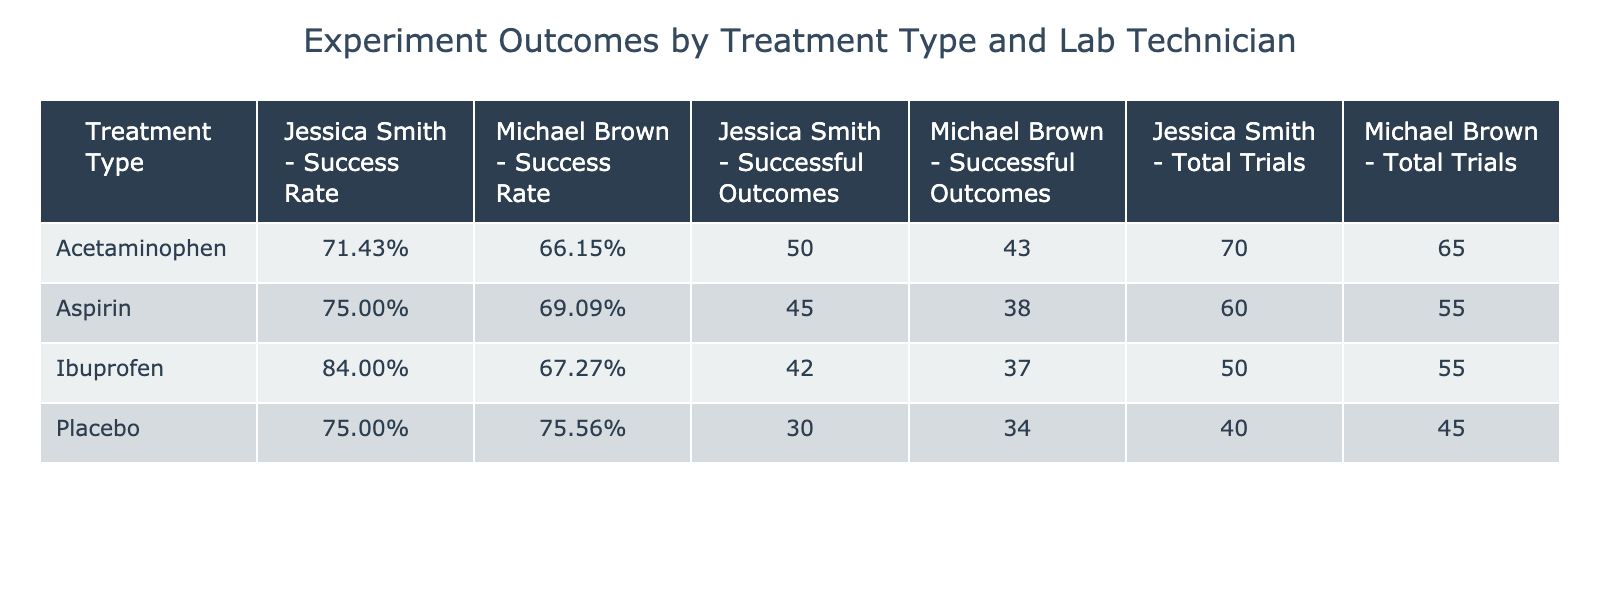What is the success rate for Aspirin when administered by Jessica Smith? To find this, locate the row corresponding to Aspirin and Jessica Smith in the table. The success rate is given as 45 successful outcomes out of 60 trials. Calculating this gives 45/60 = 0.75 or 75%.
Answer: 75% Which lab technician had the highest success rate for Acetaminophen? The success rates for Acetaminophen are: Jessica Smith with 50/70 = 0.714 (71.4%) and Michael Brown with 43/65 = 0.662 (66.2%). Jessica Smith has the higher success rate.
Answer: Jessica Smith What is the average success rate for Ibuprofen across both technicians? The success rates for Ibuprofen are: Jessica Smith with 42/50 = 0.84 (84%) and Michael Brown with 37/55 = 0.673 (67.3%). Adding these gives 0.84 + 0.673 = 1.513. Dividing by 2 to find the average gives 1.513/2 = 0.7565, or 75.65%.
Answer: 75.65% Is the success rate for the placebo treatment higher with Michael Brown than with Jessica Smith? The success rates for placebo are: Michael Brown with 34/45 = 0.756 (75.6%) and Jessica Smith with 30/40 = 0.75 (75%). Therefore, 75.6% is higher than 75%.
Answer: Yes What is the total number of successful outcomes across all treatments for Michael Brown? To find this, sum the successful outcomes for Michael Brown across all treatments: Aspirin (38) + Ibuprofen (37) + Acetaminophen (43) + Placebo (34). This equals 38 + 37 + 43 + 34 = 152 successful outcomes.
Answer: 152 If both technicians used the same treatment type, how many more successful outcomes did Jessica Smith achieve for Aspirin than Michael Brown? For Aspirin, Jessica Smith had 45 successful outcomes and Michael Brown had 38 successful outcomes. The difference is 45 - 38 = 7 successful outcomes more for Jessica Smith.
Answer: 7 